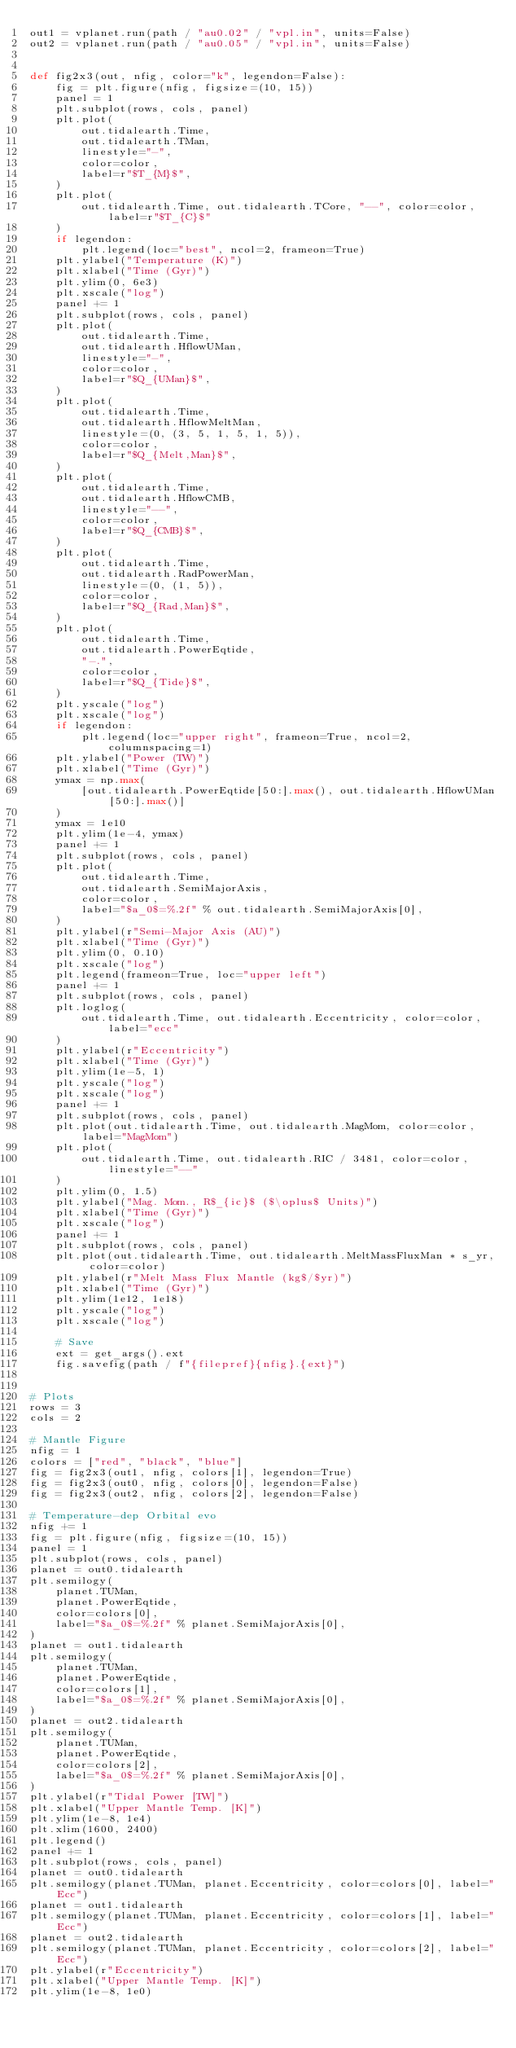<code> <loc_0><loc_0><loc_500><loc_500><_Python_>out1 = vplanet.run(path / "au0.02" / "vpl.in", units=False)
out2 = vplanet.run(path / "au0.05" / "vpl.in", units=False)


def fig2x3(out, nfig, color="k", legendon=False):
    fig = plt.figure(nfig, figsize=(10, 15))
    panel = 1
    plt.subplot(rows, cols, panel)
    plt.plot(
        out.tidalearth.Time,
        out.tidalearth.TMan,
        linestyle="-",
        color=color,
        label=r"$T_{M}$",
    )
    plt.plot(
        out.tidalearth.Time, out.tidalearth.TCore, "--", color=color, label=r"$T_{C}$"
    )
    if legendon:
        plt.legend(loc="best", ncol=2, frameon=True)
    plt.ylabel("Temperature (K)")
    plt.xlabel("Time (Gyr)")
    plt.ylim(0, 6e3)
    plt.xscale("log")
    panel += 1
    plt.subplot(rows, cols, panel)
    plt.plot(
        out.tidalearth.Time,
        out.tidalearth.HflowUMan,
        linestyle="-",
        color=color,
        label=r"$Q_{UMan}$",
    )
    plt.plot(
        out.tidalearth.Time,
        out.tidalearth.HflowMeltMan,
        linestyle=(0, (3, 5, 1, 5, 1, 5)),
        color=color,
        label=r"$Q_{Melt,Man}$",
    )
    plt.plot(
        out.tidalearth.Time,
        out.tidalearth.HflowCMB,
        linestyle="--",
        color=color,
        label=r"$Q_{CMB}$",
    )
    plt.plot(
        out.tidalearth.Time,
        out.tidalearth.RadPowerMan,
        linestyle=(0, (1, 5)),
        color=color,
        label=r"$Q_{Rad,Man}$",
    )
    plt.plot(
        out.tidalearth.Time,
        out.tidalearth.PowerEqtide,
        "-.",
        color=color,
        label=r"$Q_{Tide}$",
    )
    plt.yscale("log")
    plt.xscale("log")
    if legendon:
        plt.legend(loc="upper right", frameon=True, ncol=2, columnspacing=1)
    plt.ylabel("Power (TW)")
    plt.xlabel("Time (Gyr)")
    ymax = np.max(
        [out.tidalearth.PowerEqtide[50:].max(), out.tidalearth.HflowUMan[50:].max()]
    )
    ymax = 1e10
    plt.ylim(1e-4, ymax)
    panel += 1
    plt.subplot(rows, cols, panel)
    plt.plot(
        out.tidalearth.Time,
        out.tidalearth.SemiMajorAxis,
        color=color,
        label="$a_0$=%.2f" % out.tidalearth.SemiMajorAxis[0],
    )
    plt.ylabel(r"Semi-Major Axis (AU)")
    plt.xlabel("Time (Gyr)")
    plt.ylim(0, 0.10)
    plt.xscale("log")
    plt.legend(frameon=True, loc="upper left")
    panel += 1
    plt.subplot(rows, cols, panel)
    plt.loglog(
        out.tidalearth.Time, out.tidalearth.Eccentricity, color=color, label="ecc"
    )
    plt.ylabel(r"Eccentricity")
    plt.xlabel("Time (Gyr)")
    plt.ylim(1e-5, 1)
    plt.yscale("log")
    plt.xscale("log")
    panel += 1
    plt.subplot(rows, cols, panel)
    plt.plot(out.tidalearth.Time, out.tidalearth.MagMom, color=color, label="MagMom")
    plt.plot(
        out.tidalearth.Time, out.tidalearth.RIC / 3481, color=color, linestyle="--"
    )
    plt.ylim(0, 1.5)
    plt.ylabel("Mag. Mom., R$_{ic}$ ($\oplus$ Units)")
    plt.xlabel("Time (Gyr)")
    plt.xscale("log")
    panel += 1
    plt.subplot(rows, cols, panel)
    plt.plot(out.tidalearth.Time, out.tidalearth.MeltMassFluxMan * s_yr, color=color)
    plt.ylabel(r"Melt Mass Flux Mantle (kg$/$yr)")
    plt.xlabel("Time (Gyr)")
    plt.ylim(1e12, 1e18)
    plt.yscale("log")
    plt.xscale("log")

    # Save
    ext = get_args().ext
    fig.savefig(path / f"{filepref}{nfig}.{ext}")


# Plots
rows = 3
cols = 2

# Mantle Figure
nfig = 1
colors = ["red", "black", "blue"]
fig = fig2x3(out1, nfig, colors[1], legendon=True)
fig = fig2x3(out0, nfig, colors[0], legendon=False)
fig = fig2x3(out2, nfig, colors[2], legendon=False)

# Temperature-dep Orbital evo
nfig += 1
fig = plt.figure(nfig, figsize=(10, 15))
panel = 1
plt.subplot(rows, cols, panel)
planet = out0.tidalearth
plt.semilogy(
    planet.TUMan,
    planet.PowerEqtide,
    color=colors[0],
    label="$a_0$=%.2f" % planet.SemiMajorAxis[0],
)
planet = out1.tidalearth
plt.semilogy(
    planet.TUMan,
    planet.PowerEqtide,
    color=colors[1],
    label="$a_0$=%.2f" % planet.SemiMajorAxis[0],
)
planet = out2.tidalearth
plt.semilogy(
    planet.TUMan,
    planet.PowerEqtide,
    color=colors[2],
    label="$a_0$=%.2f" % planet.SemiMajorAxis[0],
)
plt.ylabel(r"Tidal Power [TW]")
plt.xlabel("Upper Mantle Temp. [K]")
plt.ylim(1e-8, 1e4)
plt.xlim(1600, 2400)
plt.legend()
panel += 1
plt.subplot(rows, cols, panel)
planet = out0.tidalearth
plt.semilogy(planet.TUMan, planet.Eccentricity, color=colors[0], label="Ecc")
planet = out1.tidalearth
plt.semilogy(planet.TUMan, planet.Eccentricity, color=colors[1], label="Ecc")
planet = out2.tidalearth
plt.semilogy(planet.TUMan, planet.Eccentricity, color=colors[2], label="Ecc")
plt.ylabel(r"Eccentricity")
plt.xlabel("Upper Mantle Temp. [K]")
plt.ylim(1e-8, 1e0)</code> 